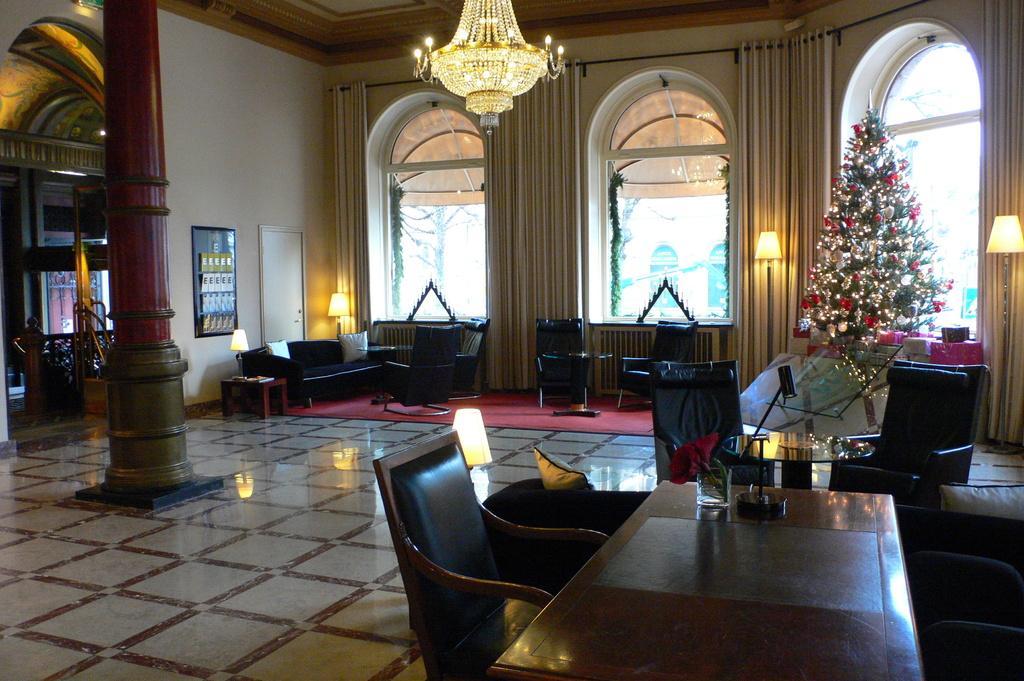Can you describe this image briefly? In this image, we can see black chairs, sofa. On right side, there is a table, few items are placed on it. And lamphere , cream color curtains. There is a plant and few gift boxes are here. And at the background, we can see glass window and curtains. Top of the image, there is a chandelier. On left side, red color pillar we can see and fencing here and door here. 